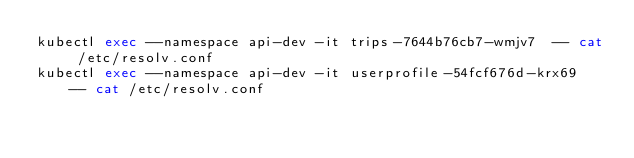<code> <loc_0><loc_0><loc_500><loc_500><_Bash_>kubectl exec --namespace api-dev -it trips-7644b76cb7-wmjv7  -- cat /etc/resolv.conf
kubectl exec --namespace api-dev -it userprofile-54fcf676d-krx69  -- cat /etc/resolv.conf
</code> 